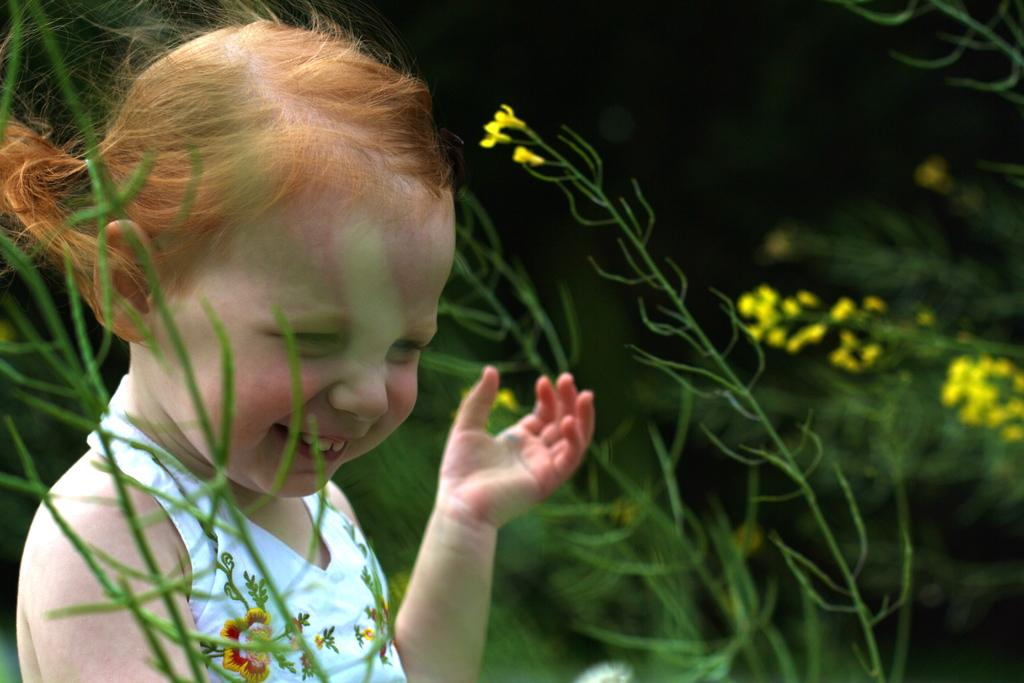Who is the main subject in the image? There is a girl in the image. What is the girl's expression in the image? The girl is smiling in the image. Where is the girl located in the image? The girl is on the left side of the image. What can be seen in the background of the image? There are plants and flowers in the background of the image. How would you describe the background of the image? The background is blurry in the image. What grade did the girl receive for her performance in the shop? There is no mention of a shop or performance in the image, and therefore no grade can be assigned. 